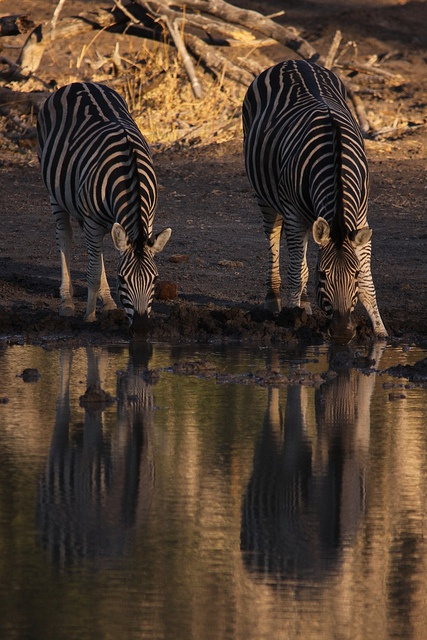Describe the objects in this image and their specific colors. I can see zebra in orange, black, gray, and maroon tones and zebra in orange, black, and gray tones in this image. 